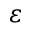<formula> <loc_0><loc_0><loc_500><loc_500>\varepsilon</formula> 